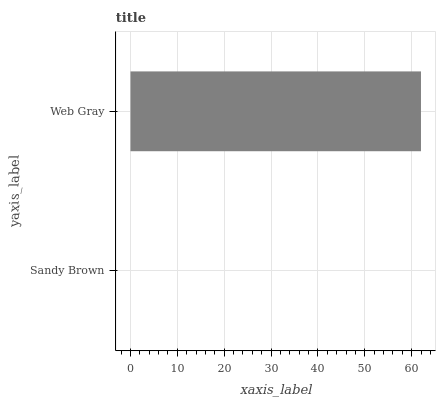Is Sandy Brown the minimum?
Answer yes or no. Yes. Is Web Gray the maximum?
Answer yes or no. Yes. Is Web Gray the minimum?
Answer yes or no. No. Is Web Gray greater than Sandy Brown?
Answer yes or no. Yes. Is Sandy Brown less than Web Gray?
Answer yes or no. Yes. Is Sandy Brown greater than Web Gray?
Answer yes or no. No. Is Web Gray less than Sandy Brown?
Answer yes or no. No. Is Web Gray the high median?
Answer yes or no. Yes. Is Sandy Brown the low median?
Answer yes or no. Yes. Is Sandy Brown the high median?
Answer yes or no. No. Is Web Gray the low median?
Answer yes or no. No. 